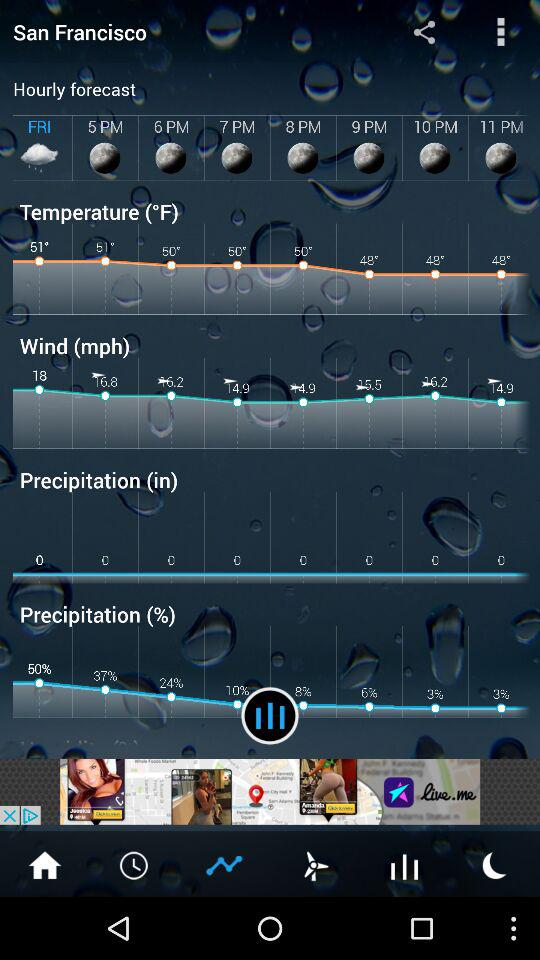How many more degrees is the highest temperature than the lowest temperature in the hourly forecast?
Answer the question using a single word or phrase. 3 